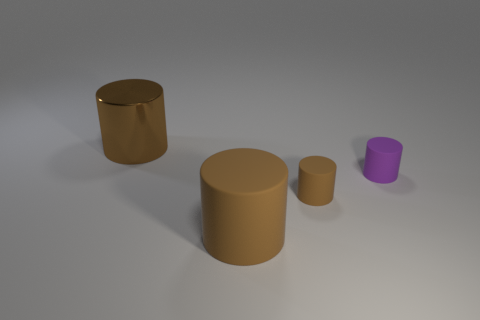Subtract all yellow blocks. How many brown cylinders are left? 3 Subtract 1 cylinders. How many cylinders are left? 3 Add 4 red matte cubes. How many objects exist? 8 Add 3 purple things. How many purple things exist? 4 Subtract 1 brown cylinders. How many objects are left? 3 Subtract all green rubber balls. Subtract all rubber objects. How many objects are left? 1 Add 3 metallic cylinders. How many metallic cylinders are left? 4 